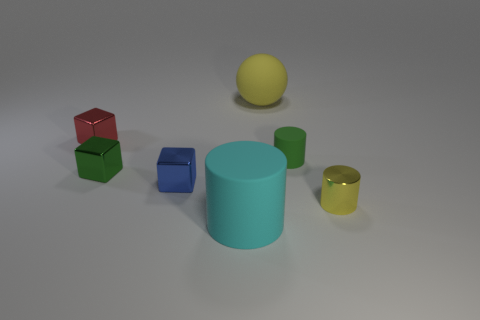Subtract all gray blocks. Subtract all gray cylinders. How many blocks are left? 3 Add 1 big things. How many objects exist? 8 Subtract all balls. How many objects are left? 6 Subtract 1 yellow balls. How many objects are left? 6 Subtract all green metal balls. Subtract all big rubber objects. How many objects are left? 5 Add 7 red cubes. How many red cubes are left? 8 Add 2 tiny green cubes. How many tiny green cubes exist? 3 